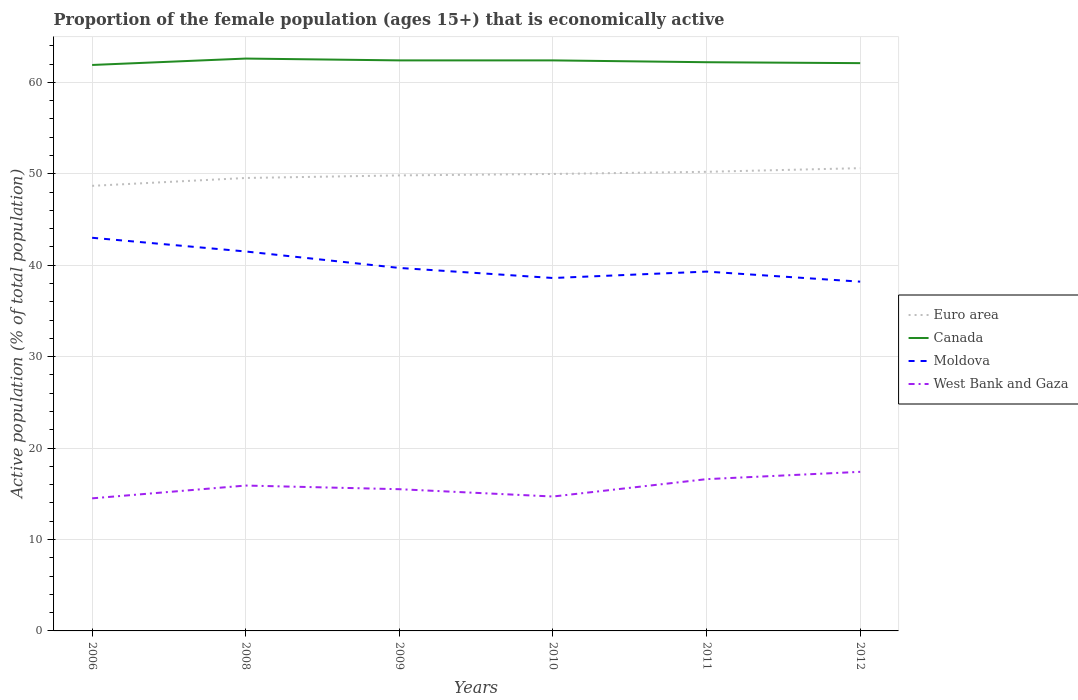Is the number of lines equal to the number of legend labels?
Provide a succinct answer. Yes. Across all years, what is the maximum proportion of the female population that is economically active in Moldova?
Offer a terse response. 38.2. In which year was the proportion of the female population that is economically active in Euro area maximum?
Keep it short and to the point. 2006. What is the total proportion of the female population that is economically active in Canada in the graph?
Provide a short and direct response. -0.5. What is the difference between the highest and the second highest proportion of the female population that is economically active in Moldova?
Offer a terse response. 4.8. Is the proportion of the female population that is economically active in West Bank and Gaza strictly greater than the proportion of the female population that is economically active in Euro area over the years?
Give a very brief answer. Yes. What is the difference between two consecutive major ticks on the Y-axis?
Make the answer very short. 10. Are the values on the major ticks of Y-axis written in scientific E-notation?
Offer a terse response. No. How many legend labels are there?
Provide a succinct answer. 4. What is the title of the graph?
Make the answer very short. Proportion of the female population (ages 15+) that is economically active. What is the label or title of the X-axis?
Offer a terse response. Years. What is the label or title of the Y-axis?
Your answer should be compact. Active population (% of total population). What is the Active population (% of total population) of Euro area in 2006?
Your answer should be very brief. 48.68. What is the Active population (% of total population) in Canada in 2006?
Make the answer very short. 61.9. What is the Active population (% of total population) of West Bank and Gaza in 2006?
Make the answer very short. 14.5. What is the Active population (% of total population) in Euro area in 2008?
Offer a terse response. 49.54. What is the Active population (% of total population) in Canada in 2008?
Ensure brevity in your answer.  62.6. What is the Active population (% of total population) of Moldova in 2008?
Keep it short and to the point. 41.5. What is the Active population (% of total population) in West Bank and Gaza in 2008?
Your answer should be very brief. 15.9. What is the Active population (% of total population) of Euro area in 2009?
Provide a short and direct response. 49.82. What is the Active population (% of total population) of Canada in 2009?
Offer a very short reply. 62.4. What is the Active population (% of total population) of Moldova in 2009?
Give a very brief answer. 39.7. What is the Active population (% of total population) of West Bank and Gaza in 2009?
Provide a succinct answer. 15.5. What is the Active population (% of total population) in Euro area in 2010?
Your answer should be very brief. 49.98. What is the Active population (% of total population) in Canada in 2010?
Make the answer very short. 62.4. What is the Active population (% of total population) of Moldova in 2010?
Your answer should be compact. 38.6. What is the Active population (% of total population) of West Bank and Gaza in 2010?
Offer a very short reply. 14.7. What is the Active population (% of total population) of Euro area in 2011?
Your answer should be compact. 50.22. What is the Active population (% of total population) of Canada in 2011?
Ensure brevity in your answer.  62.2. What is the Active population (% of total population) in Moldova in 2011?
Provide a succinct answer. 39.3. What is the Active population (% of total population) in West Bank and Gaza in 2011?
Your response must be concise. 16.6. What is the Active population (% of total population) of Euro area in 2012?
Your response must be concise. 50.61. What is the Active population (% of total population) of Canada in 2012?
Your response must be concise. 62.1. What is the Active population (% of total population) in Moldova in 2012?
Your answer should be very brief. 38.2. What is the Active population (% of total population) of West Bank and Gaza in 2012?
Ensure brevity in your answer.  17.4. Across all years, what is the maximum Active population (% of total population) in Euro area?
Keep it short and to the point. 50.61. Across all years, what is the maximum Active population (% of total population) of Canada?
Keep it short and to the point. 62.6. Across all years, what is the maximum Active population (% of total population) in Moldova?
Provide a short and direct response. 43. Across all years, what is the maximum Active population (% of total population) of West Bank and Gaza?
Your response must be concise. 17.4. Across all years, what is the minimum Active population (% of total population) of Euro area?
Provide a short and direct response. 48.68. Across all years, what is the minimum Active population (% of total population) of Canada?
Ensure brevity in your answer.  61.9. Across all years, what is the minimum Active population (% of total population) in Moldova?
Provide a succinct answer. 38.2. What is the total Active population (% of total population) of Euro area in the graph?
Provide a succinct answer. 298.85. What is the total Active population (% of total population) of Canada in the graph?
Your answer should be very brief. 373.6. What is the total Active population (% of total population) in Moldova in the graph?
Your answer should be compact. 240.3. What is the total Active population (% of total population) in West Bank and Gaza in the graph?
Offer a very short reply. 94.6. What is the difference between the Active population (% of total population) of Euro area in 2006 and that in 2008?
Your response must be concise. -0.86. What is the difference between the Active population (% of total population) of West Bank and Gaza in 2006 and that in 2008?
Give a very brief answer. -1.4. What is the difference between the Active population (% of total population) of Euro area in 2006 and that in 2009?
Provide a succinct answer. -1.14. What is the difference between the Active population (% of total population) of Moldova in 2006 and that in 2009?
Offer a terse response. 3.3. What is the difference between the Active population (% of total population) in Euro area in 2006 and that in 2010?
Provide a short and direct response. -1.3. What is the difference between the Active population (% of total population) of Moldova in 2006 and that in 2010?
Offer a very short reply. 4.4. What is the difference between the Active population (% of total population) in Euro area in 2006 and that in 2011?
Offer a terse response. -1.54. What is the difference between the Active population (% of total population) in Moldova in 2006 and that in 2011?
Provide a short and direct response. 3.7. What is the difference between the Active population (% of total population) in Euro area in 2006 and that in 2012?
Make the answer very short. -1.93. What is the difference between the Active population (% of total population) of West Bank and Gaza in 2006 and that in 2012?
Your response must be concise. -2.9. What is the difference between the Active population (% of total population) in Euro area in 2008 and that in 2009?
Your answer should be very brief. -0.28. What is the difference between the Active population (% of total population) in Euro area in 2008 and that in 2010?
Your answer should be compact. -0.44. What is the difference between the Active population (% of total population) in Moldova in 2008 and that in 2010?
Offer a terse response. 2.9. What is the difference between the Active population (% of total population) of West Bank and Gaza in 2008 and that in 2010?
Provide a short and direct response. 1.2. What is the difference between the Active population (% of total population) of Euro area in 2008 and that in 2011?
Provide a short and direct response. -0.68. What is the difference between the Active population (% of total population) of Canada in 2008 and that in 2011?
Offer a very short reply. 0.4. What is the difference between the Active population (% of total population) of Moldova in 2008 and that in 2011?
Offer a terse response. 2.2. What is the difference between the Active population (% of total population) of West Bank and Gaza in 2008 and that in 2011?
Your answer should be compact. -0.7. What is the difference between the Active population (% of total population) of Euro area in 2008 and that in 2012?
Ensure brevity in your answer.  -1.07. What is the difference between the Active population (% of total population) in West Bank and Gaza in 2008 and that in 2012?
Keep it short and to the point. -1.5. What is the difference between the Active population (% of total population) of Euro area in 2009 and that in 2010?
Your response must be concise. -0.16. What is the difference between the Active population (% of total population) in Canada in 2009 and that in 2010?
Give a very brief answer. 0. What is the difference between the Active population (% of total population) of West Bank and Gaza in 2009 and that in 2010?
Make the answer very short. 0.8. What is the difference between the Active population (% of total population) of Euro area in 2009 and that in 2011?
Offer a terse response. -0.39. What is the difference between the Active population (% of total population) of Moldova in 2009 and that in 2011?
Provide a succinct answer. 0.4. What is the difference between the Active population (% of total population) in Euro area in 2009 and that in 2012?
Provide a short and direct response. -0.79. What is the difference between the Active population (% of total population) of Euro area in 2010 and that in 2011?
Your response must be concise. -0.24. What is the difference between the Active population (% of total population) of West Bank and Gaza in 2010 and that in 2011?
Provide a short and direct response. -1.9. What is the difference between the Active population (% of total population) of Euro area in 2010 and that in 2012?
Ensure brevity in your answer.  -0.63. What is the difference between the Active population (% of total population) in Canada in 2010 and that in 2012?
Give a very brief answer. 0.3. What is the difference between the Active population (% of total population) of Euro area in 2011 and that in 2012?
Give a very brief answer. -0.4. What is the difference between the Active population (% of total population) of Moldova in 2011 and that in 2012?
Provide a short and direct response. 1.1. What is the difference between the Active population (% of total population) of Euro area in 2006 and the Active population (% of total population) of Canada in 2008?
Give a very brief answer. -13.92. What is the difference between the Active population (% of total population) in Euro area in 2006 and the Active population (% of total population) in Moldova in 2008?
Ensure brevity in your answer.  7.18. What is the difference between the Active population (% of total population) of Euro area in 2006 and the Active population (% of total population) of West Bank and Gaza in 2008?
Provide a succinct answer. 32.78. What is the difference between the Active population (% of total population) in Canada in 2006 and the Active population (% of total population) in Moldova in 2008?
Give a very brief answer. 20.4. What is the difference between the Active population (% of total population) in Moldova in 2006 and the Active population (% of total population) in West Bank and Gaza in 2008?
Offer a very short reply. 27.1. What is the difference between the Active population (% of total population) of Euro area in 2006 and the Active population (% of total population) of Canada in 2009?
Provide a succinct answer. -13.72. What is the difference between the Active population (% of total population) in Euro area in 2006 and the Active population (% of total population) in Moldova in 2009?
Offer a very short reply. 8.98. What is the difference between the Active population (% of total population) in Euro area in 2006 and the Active population (% of total population) in West Bank and Gaza in 2009?
Your response must be concise. 33.18. What is the difference between the Active population (% of total population) in Canada in 2006 and the Active population (% of total population) in Moldova in 2009?
Ensure brevity in your answer.  22.2. What is the difference between the Active population (% of total population) of Canada in 2006 and the Active population (% of total population) of West Bank and Gaza in 2009?
Offer a very short reply. 46.4. What is the difference between the Active population (% of total population) of Moldova in 2006 and the Active population (% of total population) of West Bank and Gaza in 2009?
Keep it short and to the point. 27.5. What is the difference between the Active population (% of total population) in Euro area in 2006 and the Active population (% of total population) in Canada in 2010?
Give a very brief answer. -13.72. What is the difference between the Active population (% of total population) of Euro area in 2006 and the Active population (% of total population) of Moldova in 2010?
Provide a succinct answer. 10.08. What is the difference between the Active population (% of total population) of Euro area in 2006 and the Active population (% of total population) of West Bank and Gaza in 2010?
Offer a very short reply. 33.98. What is the difference between the Active population (% of total population) of Canada in 2006 and the Active population (% of total population) of Moldova in 2010?
Ensure brevity in your answer.  23.3. What is the difference between the Active population (% of total population) in Canada in 2006 and the Active population (% of total population) in West Bank and Gaza in 2010?
Offer a very short reply. 47.2. What is the difference between the Active population (% of total population) of Moldova in 2006 and the Active population (% of total population) of West Bank and Gaza in 2010?
Ensure brevity in your answer.  28.3. What is the difference between the Active population (% of total population) in Euro area in 2006 and the Active population (% of total population) in Canada in 2011?
Your answer should be very brief. -13.52. What is the difference between the Active population (% of total population) in Euro area in 2006 and the Active population (% of total population) in Moldova in 2011?
Your answer should be very brief. 9.38. What is the difference between the Active population (% of total population) in Euro area in 2006 and the Active population (% of total population) in West Bank and Gaza in 2011?
Ensure brevity in your answer.  32.08. What is the difference between the Active population (% of total population) of Canada in 2006 and the Active population (% of total population) of Moldova in 2011?
Offer a terse response. 22.6. What is the difference between the Active population (% of total population) of Canada in 2006 and the Active population (% of total population) of West Bank and Gaza in 2011?
Keep it short and to the point. 45.3. What is the difference between the Active population (% of total population) in Moldova in 2006 and the Active population (% of total population) in West Bank and Gaza in 2011?
Your response must be concise. 26.4. What is the difference between the Active population (% of total population) of Euro area in 2006 and the Active population (% of total population) of Canada in 2012?
Keep it short and to the point. -13.42. What is the difference between the Active population (% of total population) of Euro area in 2006 and the Active population (% of total population) of Moldova in 2012?
Provide a succinct answer. 10.48. What is the difference between the Active population (% of total population) in Euro area in 2006 and the Active population (% of total population) in West Bank and Gaza in 2012?
Ensure brevity in your answer.  31.28. What is the difference between the Active population (% of total population) of Canada in 2006 and the Active population (% of total population) of Moldova in 2012?
Provide a short and direct response. 23.7. What is the difference between the Active population (% of total population) in Canada in 2006 and the Active population (% of total population) in West Bank and Gaza in 2012?
Offer a very short reply. 44.5. What is the difference between the Active population (% of total population) of Moldova in 2006 and the Active population (% of total population) of West Bank and Gaza in 2012?
Your response must be concise. 25.6. What is the difference between the Active population (% of total population) in Euro area in 2008 and the Active population (% of total population) in Canada in 2009?
Offer a terse response. -12.86. What is the difference between the Active population (% of total population) of Euro area in 2008 and the Active population (% of total population) of Moldova in 2009?
Offer a terse response. 9.84. What is the difference between the Active population (% of total population) of Euro area in 2008 and the Active population (% of total population) of West Bank and Gaza in 2009?
Your answer should be compact. 34.04. What is the difference between the Active population (% of total population) of Canada in 2008 and the Active population (% of total population) of Moldova in 2009?
Keep it short and to the point. 22.9. What is the difference between the Active population (% of total population) of Canada in 2008 and the Active population (% of total population) of West Bank and Gaza in 2009?
Make the answer very short. 47.1. What is the difference between the Active population (% of total population) in Moldova in 2008 and the Active population (% of total population) in West Bank and Gaza in 2009?
Your answer should be very brief. 26. What is the difference between the Active population (% of total population) in Euro area in 2008 and the Active population (% of total population) in Canada in 2010?
Your response must be concise. -12.86. What is the difference between the Active population (% of total population) of Euro area in 2008 and the Active population (% of total population) of Moldova in 2010?
Ensure brevity in your answer.  10.94. What is the difference between the Active population (% of total population) of Euro area in 2008 and the Active population (% of total population) of West Bank and Gaza in 2010?
Make the answer very short. 34.84. What is the difference between the Active population (% of total population) in Canada in 2008 and the Active population (% of total population) in West Bank and Gaza in 2010?
Your response must be concise. 47.9. What is the difference between the Active population (% of total population) of Moldova in 2008 and the Active population (% of total population) of West Bank and Gaza in 2010?
Your answer should be compact. 26.8. What is the difference between the Active population (% of total population) in Euro area in 2008 and the Active population (% of total population) in Canada in 2011?
Make the answer very short. -12.66. What is the difference between the Active population (% of total population) of Euro area in 2008 and the Active population (% of total population) of Moldova in 2011?
Your answer should be compact. 10.24. What is the difference between the Active population (% of total population) of Euro area in 2008 and the Active population (% of total population) of West Bank and Gaza in 2011?
Make the answer very short. 32.94. What is the difference between the Active population (% of total population) of Canada in 2008 and the Active population (% of total population) of Moldova in 2011?
Ensure brevity in your answer.  23.3. What is the difference between the Active population (% of total population) in Moldova in 2008 and the Active population (% of total population) in West Bank and Gaza in 2011?
Your answer should be compact. 24.9. What is the difference between the Active population (% of total population) of Euro area in 2008 and the Active population (% of total population) of Canada in 2012?
Your answer should be compact. -12.56. What is the difference between the Active population (% of total population) of Euro area in 2008 and the Active population (% of total population) of Moldova in 2012?
Keep it short and to the point. 11.34. What is the difference between the Active population (% of total population) in Euro area in 2008 and the Active population (% of total population) in West Bank and Gaza in 2012?
Offer a very short reply. 32.14. What is the difference between the Active population (% of total population) in Canada in 2008 and the Active population (% of total population) in Moldova in 2012?
Give a very brief answer. 24.4. What is the difference between the Active population (% of total population) in Canada in 2008 and the Active population (% of total population) in West Bank and Gaza in 2012?
Your answer should be very brief. 45.2. What is the difference between the Active population (% of total population) of Moldova in 2008 and the Active population (% of total population) of West Bank and Gaza in 2012?
Make the answer very short. 24.1. What is the difference between the Active population (% of total population) in Euro area in 2009 and the Active population (% of total population) in Canada in 2010?
Offer a very short reply. -12.58. What is the difference between the Active population (% of total population) in Euro area in 2009 and the Active population (% of total population) in Moldova in 2010?
Make the answer very short. 11.22. What is the difference between the Active population (% of total population) in Euro area in 2009 and the Active population (% of total population) in West Bank and Gaza in 2010?
Make the answer very short. 35.12. What is the difference between the Active population (% of total population) of Canada in 2009 and the Active population (% of total population) of Moldova in 2010?
Provide a succinct answer. 23.8. What is the difference between the Active population (% of total population) of Canada in 2009 and the Active population (% of total population) of West Bank and Gaza in 2010?
Provide a succinct answer. 47.7. What is the difference between the Active population (% of total population) in Moldova in 2009 and the Active population (% of total population) in West Bank and Gaza in 2010?
Provide a succinct answer. 25. What is the difference between the Active population (% of total population) in Euro area in 2009 and the Active population (% of total population) in Canada in 2011?
Your response must be concise. -12.38. What is the difference between the Active population (% of total population) in Euro area in 2009 and the Active population (% of total population) in Moldova in 2011?
Offer a terse response. 10.52. What is the difference between the Active population (% of total population) in Euro area in 2009 and the Active population (% of total population) in West Bank and Gaza in 2011?
Make the answer very short. 33.22. What is the difference between the Active population (% of total population) of Canada in 2009 and the Active population (% of total population) of Moldova in 2011?
Make the answer very short. 23.1. What is the difference between the Active population (% of total population) in Canada in 2009 and the Active population (% of total population) in West Bank and Gaza in 2011?
Your answer should be very brief. 45.8. What is the difference between the Active population (% of total population) of Moldova in 2009 and the Active population (% of total population) of West Bank and Gaza in 2011?
Offer a very short reply. 23.1. What is the difference between the Active population (% of total population) of Euro area in 2009 and the Active population (% of total population) of Canada in 2012?
Keep it short and to the point. -12.28. What is the difference between the Active population (% of total population) of Euro area in 2009 and the Active population (% of total population) of Moldova in 2012?
Your response must be concise. 11.62. What is the difference between the Active population (% of total population) in Euro area in 2009 and the Active population (% of total population) in West Bank and Gaza in 2012?
Your response must be concise. 32.42. What is the difference between the Active population (% of total population) of Canada in 2009 and the Active population (% of total population) of Moldova in 2012?
Keep it short and to the point. 24.2. What is the difference between the Active population (% of total population) in Moldova in 2009 and the Active population (% of total population) in West Bank and Gaza in 2012?
Your response must be concise. 22.3. What is the difference between the Active population (% of total population) in Euro area in 2010 and the Active population (% of total population) in Canada in 2011?
Your answer should be compact. -12.22. What is the difference between the Active population (% of total population) of Euro area in 2010 and the Active population (% of total population) of Moldova in 2011?
Offer a terse response. 10.68. What is the difference between the Active population (% of total population) of Euro area in 2010 and the Active population (% of total population) of West Bank and Gaza in 2011?
Provide a succinct answer. 33.38. What is the difference between the Active population (% of total population) in Canada in 2010 and the Active population (% of total population) in Moldova in 2011?
Give a very brief answer. 23.1. What is the difference between the Active population (% of total population) of Canada in 2010 and the Active population (% of total population) of West Bank and Gaza in 2011?
Provide a short and direct response. 45.8. What is the difference between the Active population (% of total population) of Moldova in 2010 and the Active population (% of total population) of West Bank and Gaza in 2011?
Your answer should be very brief. 22. What is the difference between the Active population (% of total population) of Euro area in 2010 and the Active population (% of total population) of Canada in 2012?
Your answer should be very brief. -12.12. What is the difference between the Active population (% of total population) of Euro area in 2010 and the Active population (% of total population) of Moldova in 2012?
Make the answer very short. 11.78. What is the difference between the Active population (% of total population) in Euro area in 2010 and the Active population (% of total population) in West Bank and Gaza in 2012?
Provide a succinct answer. 32.58. What is the difference between the Active population (% of total population) of Canada in 2010 and the Active population (% of total population) of Moldova in 2012?
Give a very brief answer. 24.2. What is the difference between the Active population (% of total population) in Canada in 2010 and the Active population (% of total population) in West Bank and Gaza in 2012?
Offer a very short reply. 45. What is the difference between the Active population (% of total population) in Moldova in 2010 and the Active population (% of total population) in West Bank and Gaza in 2012?
Ensure brevity in your answer.  21.2. What is the difference between the Active population (% of total population) in Euro area in 2011 and the Active population (% of total population) in Canada in 2012?
Provide a succinct answer. -11.88. What is the difference between the Active population (% of total population) in Euro area in 2011 and the Active population (% of total population) in Moldova in 2012?
Keep it short and to the point. 12.02. What is the difference between the Active population (% of total population) of Euro area in 2011 and the Active population (% of total population) of West Bank and Gaza in 2012?
Your response must be concise. 32.82. What is the difference between the Active population (% of total population) in Canada in 2011 and the Active population (% of total population) in West Bank and Gaza in 2012?
Your answer should be compact. 44.8. What is the difference between the Active population (% of total population) of Moldova in 2011 and the Active population (% of total population) of West Bank and Gaza in 2012?
Offer a very short reply. 21.9. What is the average Active population (% of total population) of Euro area per year?
Provide a succinct answer. 49.81. What is the average Active population (% of total population) of Canada per year?
Your answer should be very brief. 62.27. What is the average Active population (% of total population) of Moldova per year?
Your answer should be very brief. 40.05. What is the average Active population (% of total population) in West Bank and Gaza per year?
Your answer should be very brief. 15.77. In the year 2006, what is the difference between the Active population (% of total population) of Euro area and Active population (% of total population) of Canada?
Give a very brief answer. -13.22. In the year 2006, what is the difference between the Active population (% of total population) in Euro area and Active population (% of total population) in Moldova?
Your answer should be compact. 5.68. In the year 2006, what is the difference between the Active population (% of total population) of Euro area and Active population (% of total population) of West Bank and Gaza?
Provide a succinct answer. 34.18. In the year 2006, what is the difference between the Active population (% of total population) of Canada and Active population (% of total population) of Moldova?
Provide a short and direct response. 18.9. In the year 2006, what is the difference between the Active population (% of total population) in Canada and Active population (% of total population) in West Bank and Gaza?
Make the answer very short. 47.4. In the year 2008, what is the difference between the Active population (% of total population) of Euro area and Active population (% of total population) of Canada?
Make the answer very short. -13.06. In the year 2008, what is the difference between the Active population (% of total population) in Euro area and Active population (% of total population) in Moldova?
Keep it short and to the point. 8.04. In the year 2008, what is the difference between the Active population (% of total population) in Euro area and Active population (% of total population) in West Bank and Gaza?
Give a very brief answer. 33.64. In the year 2008, what is the difference between the Active population (% of total population) in Canada and Active population (% of total population) in Moldova?
Ensure brevity in your answer.  21.1. In the year 2008, what is the difference between the Active population (% of total population) of Canada and Active population (% of total population) of West Bank and Gaza?
Offer a terse response. 46.7. In the year 2008, what is the difference between the Active population (% of total population) of Moldova and Active population (% of total population) of West Bank and Gaza?
Your response must be concise. 25.6. In the year 2009, what is the difference between the Active population (% of total population) of Euro area and Active population (% of total population) of Canada?
Your answer should be very brief. -12.58. In the year 2009, what is the difference between the Active population (% of total population) in Euro area and Active population (% of total population) in Moldova?
Your response must be concise. 10.12. In the year 2009, what is the difference between the Active population (% of total population) of Euro area and Active population (% of total population) of West Bank and Gaza?
Ensure brevity in your answer.  34.32. In the year 2009, what is the difference between the Active population (% of total population) of Canada and Active population (% of total population) of Moldova?
Your response must be concise. 22.7. In the year 2009, what is the difference between the Active population (% of total population) of Canada and Active population (% of total population) of West Bank and Gaza?
Your response must be concise. 46.9. In the year 2009, what is the difference between the Active population (% of total population) of Moldova and Active population (% of total population) of West Bank and Gaza?
Your answer should be very brief. 24.2. In the year 2010, what is the difference between the Active population (% of total population) in Euro area and Active population (% of total population) in Canada?
Your answer should be very brief. -12.42. In the year 2010, what is the difference between the Active population (% of total population) of Euro area and Active population (% of total population) of Moldova?
Provide a short and direct response. 11.38. In the year 2010, what is the difference between the Active population (% of total population) of Euro area and Active population (% of total population) of West Bank and Gaza?
Keep it short and to the point. 35.28. In the year 2010, what is the difference between the Active population (% of total population) of Canada and Active population (% of total population) of Moldova?
Give a very brief answer. 23.8. In the year 2010, what is the difference between the Active population (% of total population) of Canada and Active population (% of total population) of West Bank and Gaza?
Offer a very short reply. 47.7. In the year 2010, what is the difference between the Active population (% of total population) of Moldova and Active population (% of total population) of West Bank and Gaza?
Give a very brief answer. 23.9. In the year 2011, what is the difference between the Active population (% of total population) in Euro area and Active population (% of total population) in Canada?
Ensure brevity in your answer.  -11.98. In the year 2011, what is the difference between the Active population (% of total population) of Euro area and Active population (% of total population) of Moldova?
Offer a terse response. 10.92. In the year 2011, what is the difference between the Active population (% of total population) of Euro area and Active population (% of total population) of West Bank and Gaza?
Offer a very short reply. 33.62. In the year 2011, what is the difference between the Active population (% of total population) in Canada and Active population (% of total population) in Moldova?
Provide a succinct answer. 22.9. In the year 2011, what is the difference between the Active population (% of total population) of Canada and Active population (% of total population) of West Bank and Gaza?
Provide a short and direct response. 45.6. In the year 2011, what is the difference between the Active population (% of total population) of Moldova and Active population (% of total population) of West Bank and Gaza?
Offer a very short reply. 22.7. In the year 2012, what is the difference between the Active population (% of total population) of Euro area and Active population (% of total population) of Canada?
Give a very brief answer. -11.49. In the year 2012, what is the difference between the Active population (% of total population) in Euro area and Active population (% of total population) in Moldova?
Your answer should be very brief. 12.41. In the year 2012, what is the difference between the Active population (% of total population) in Euro area and Active population (% of total population) in West Bank and Gaza?
Make the answer very short. 33.21. In the year 2012, what is the difference between the Active population (% of total population) of Canada and Active population (% of total population) of Moldova?
Your response must be concise. 23.9. In the year 2012, what is the difference between the Active population (% of total population) in Canada and Active population (% of total population) in West Bank and Gaza?
Your response must be concise. 44.7. In the year 2012, what is the difference between the Active population (% of total population) in Moldova and Active population (% of total population) in West Bank and Gaza?
Ensure brevity in your answer.  20.8. What is the ratio of the Active population (% of total population) of Euro area in 2006 to that in 2008?
Provide a succinct answer. 0.98. What is the ratio of the Active population (% of total population) in Moldova in 2006 to that in 2008?
Make the answer very short. 1.04. What is the ratio of the Active population (% of total population) of West Bank and Gaza in 2006 to that in 2008?
Make the answer very short. 0.91. What is the ratio of the Active population (% of total population) in Euro area in 2006 to that in 2009?
Make the answer very short. 0.98. What is the ratio of the Active population (% of total population) of Canada in 2006 to that in 2009?
Your answer should be compact. 0.99. What is the ratio of the Active population (% of total population) of Moldova in 2006 to that in 2009?
Give a very brief answer. 1.08. What is the ratio of the Active population (% of total population) of West Bank and Gaza in 2006 to that in 2009?
Your response must be concise. 0.94. What is the ratio of the Active population (% of total population) of Euro area in 2006 to that in 2010?
Your answer should be very brief. 0.97. What is the ratio of the Active population (% of total population) of Canada in 2006 to that in 2010?
Your response must be concise. 0.99. What is the ratio of the Active population (% of total population) in Moldova in 2006 to that in 2010?
Your answer should be very brief. 1.11. What is the ratio of the Active population (% of total population) in West Bank and Gaza in 2006 to that in 2010?
Offer a terse response. 0.99. What is the ratio of the Active population (% of total population) in Euro area in 2006 to that in 2011?
Your answer should be very brief. 0.97. What is the ratio of the Active population (% of total population) in Moldova in 2006 to that in 2011?
Your response must be concise. 1.09. What is the ratio of the Active population (% of total population) in West Bank and Gaza in 2006 to that in 2011?
Offer a very short reply. 0.87. What is the ratio of the Active population (% of total population) in Euro area in 2006 to that in 2012?
Your answer should be very brief. 0.96. What is the ratio of the Active population (% of total population) in Moldova in 2006 to that in 2012?
Your response must be concise. 1.13. What is the ratio of the Active population (% of total population) in West Bank and Gaza in 2006 to that in 2012?
Your response must be concise. 0.83. What is the ratio of the Active population (% of total population) of Euro area in 2008 to that in 2009?
Offer a very short reply. 0.99. What is the ratio of the Active population (% of total population) of Canada in 2008 to that in 2009?
Provide a succinct answer. 1. What is the ratio of the Active population (% of total population) in Moldova in 2008 to that in 2009?
Make the answer very short. 1.05. What is the ratio of the Active population (% of total population) in West Bank and Gaza in 2008 to that in 2009?
Give a very brief answer. 1.03. What is the ratio of the Active population (% of total population) in Moldova in 2008 to that in 2010?
Your answer should be compact. 1.08. What is the ratio of the Active population (% of total population) of West Bank and Gaza in 2008 to that in 2010?
Offer a terse response. 1.08. What is the ratio of the Active population (% of total population) in Euro area in 2008 to that in 2011?
Make the answer very short. 0.99. What is the ratio of the Active population (% of total population) of Canada in 2008 to that in 2011?
Make the answer very short. 1.01. What is the ratio of the Active population (% of total population) in Moldova in 2008 to that in 2011?
Your answer should be very brief. 1.06. What is the ratio of the Active population (% of total population) of West Bank and Gaza in 2008 to that in 2011?
Provide a short and direct response. 0.96. What is the ratio of the Active population (% of total population) of Euro area in 2008 to that in 2012?
Offer a very short reply. 0.98. What is the ratio of the Active population (% of total population) in Moldova in 2008 to that in 2012?
Provide a short and direct response. 1.09. What is the ratio of the Active population (% of total population) in West Bank and Gaza in 2008 to that in 2012?
Make the answer very short. 0.91. What is the ratio of the Active population (% of total population) of Moldova in 2009 to that in 2010?
Provide a succinct answer. 1.03. What is the ratio of the Active population (% of total population) in West Bank and Gaza in 2009 to that in 2010?
Your response must be concise. 1.05. What is the ratio of the Active population (% of total population) in Euro area in 2009 to that in 2011?
Keep it short and to the point. 0.99. What is the ratio of the Active population (% of total population) in Moldova in 2009 to that in 2011?
Offer a terse response. 1.01. What is the ratio of the Active population (% of total population) of West Bank and Gaza in 2009 to that in 2011?
Provide a short and direct response. 0.93. What is the ratio of the Active population (% of total population) of Euro area in 2009 to that in 2012?
Make the answer very short. 0.98. What is the ratio of the Active population (% of total population) of Moldova in 2009 to that in 2012?
Your answer should be compact. 1.04. What is the ratio of the Active population (% of total population) in West Bank and Gaza in 2009 to that in 2012?
Make the answer very short. 0.89. What is the ratio of the Active population (% of total population) of Euro area in 2010 to that in 2011?
Offer a very short reply. 1. What is the ratio of the Active population (% of total population) in Moldova in 2010 to that in 2011?
Give a very brief answer. 0.98. What is the ratio of the Active population (% of total population) in West Bank and Gaza in 2010 to that in 2011?
Your answer should be compact. 0.89. What is the ratio of the Active population (% of total population) in Euro area in 2010 to that in 2012?
Offer a very short reply. 0.99. What is the ratio of the Active population (% of total population) of Moldova in 2010 to that in 2012?
Provide a short and direct response. 1.01. What is the ratio of the Active population (% of total population) of West Bank and Gaza in 2010 to that in 2012?
Provide a short and direct response. 0.84. What is the ratio of the Active population (% of total population) in Euro area in 2011 to that in 2012?
Your answer should be compact. 0.99. What is the ratio of the Active population (% of total population) of Canada in 2011 to that in 2012?
Your answer should be compact. 1. What is the ratio of the Active population (% of total population) of Moldova in 2011 to that in 2012?
Your response must be concise. 1.03. What is the ratio of the Active population (% of total population) in West Bank and Gaza in 2011 to that in 2012?
Your answer should be compact. 0.95. What is the difference between the highest and the second highest Active population (% of total population) in Euro area?
Ensure brevity in your answer.  0.4. What is the difference between the highest and the second highest Active population (% of total population) of Canada?
Offer a terse response. 0.2. What is the difference between the highest and the lowest Active population (% of total population) in Euro area?
Provide a succinct answer. 1.93. What is the difference between the highest and the lowest Active population (% of total population) in Canada?
Make the answer very short. 0.7. 